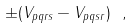Convert formula to latex. <formula><loc_0><loc_0><loc_500><loc_500>\pm ( V _ { p q r s } - V _ { p q s r } ) \ ,</formula> 